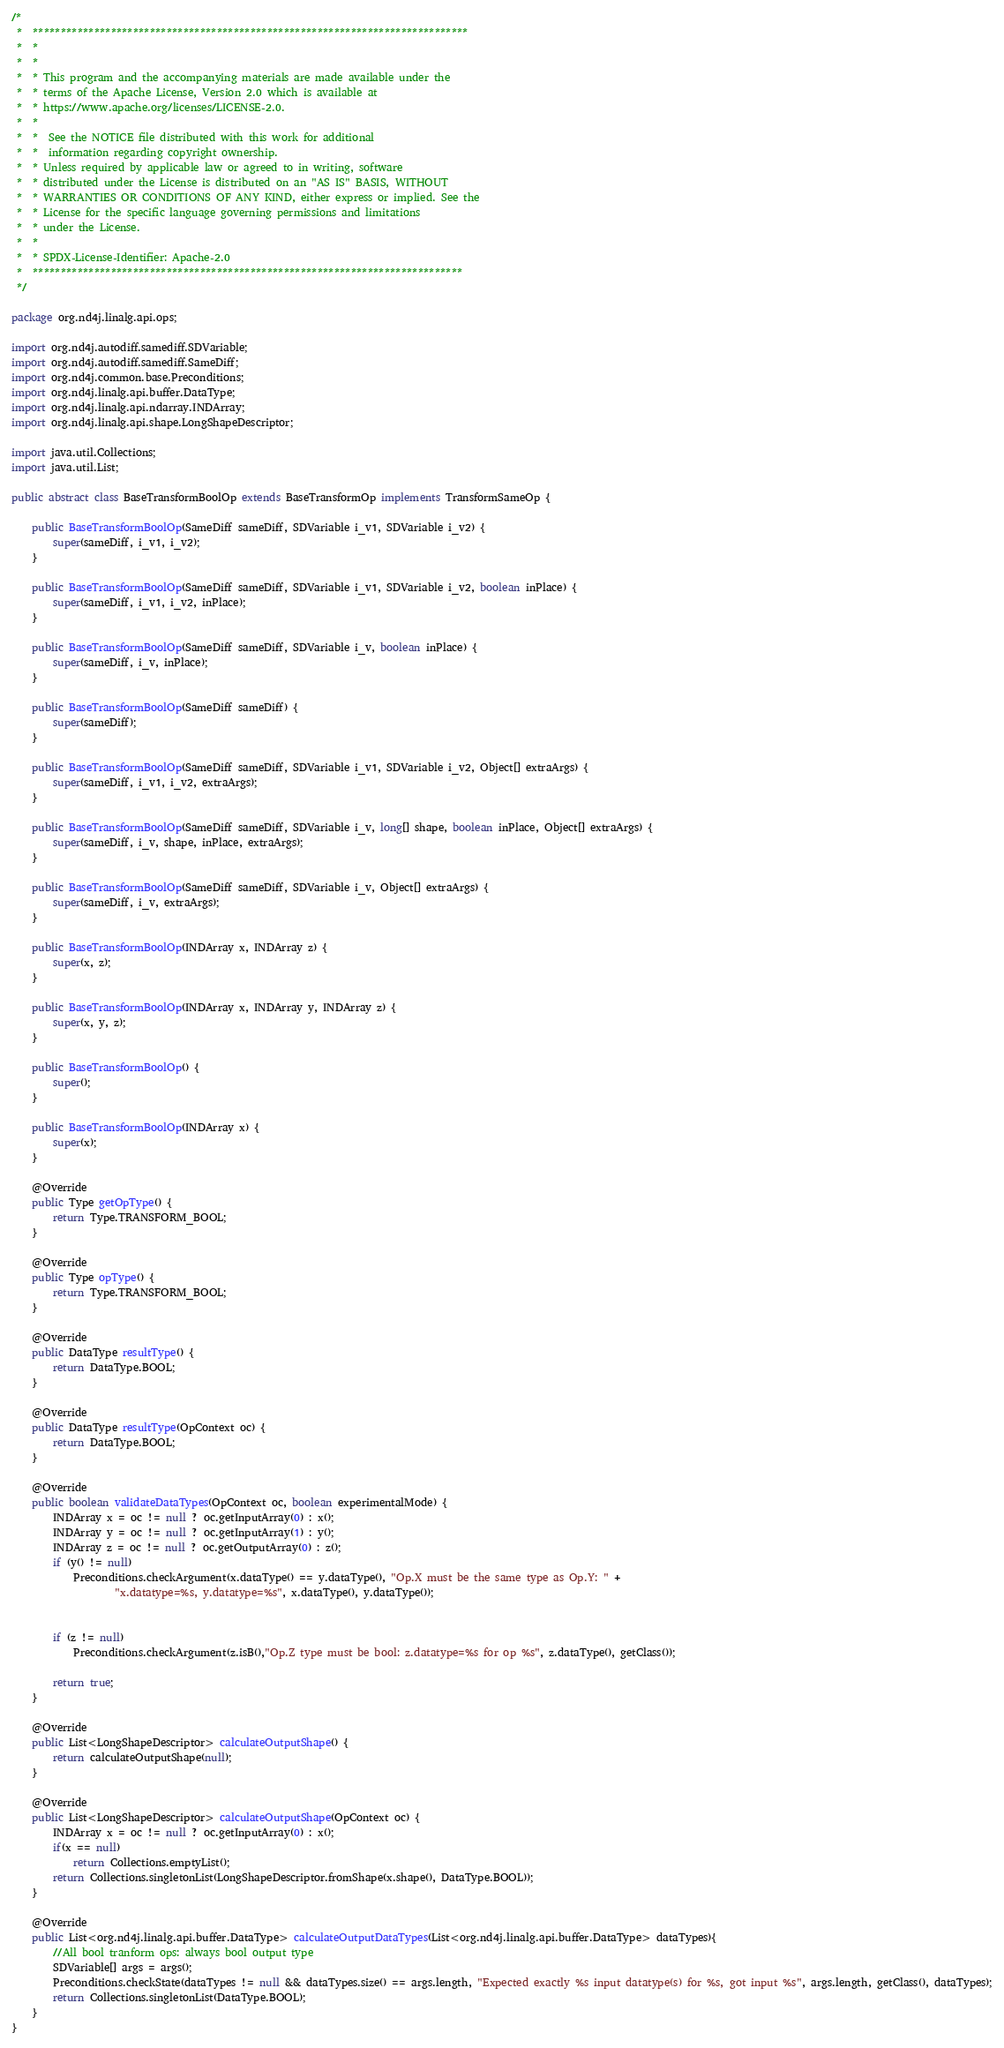<code> <loc_0><loc_0><loc_500><loc_500><_Java_>/*
 *  ******************************************************************************
 *  *
 *  *
 *  * This program and the accompanying materials are made available under the
 *  * terms of the Apache License, Version 2.0 which is available at
 *  * https://www.apache.org/licenses/LICENSE-2.0.
 *  *
 *  *  See the NOTICE file distributed with this work for additional
 *  *  information regarding copyright ownership.
 *  * Unless required by applicable law or agreed to in writing, software
 *  * distributed under the License is distributed on an "AS IS" BASIS, WITHOUT
 *  * WARRANTIES OR CONDITIONS OF ANY KIND, either express or implied. See the
 *  * License for the specific language governing permissions and limitations
 *  * under the License.
 *  *
 *  * SPDX-License-Identifier: Apache-2.0
 *  *****************************************************************************
 */

package org.nd4j.linalg.api.ops;

import org.nd4j.autodiff.samediff.SDVariable;
import org.nd4j.autodiff.samediff.SameDiff;
import org.nd4j.common.base.Preconditions;
import org.nd4j.linalg.api.buffer.DataType;
import org.nd4j.linalg.api.ndarray.INDArray;
import org.nd4j.linalg.api.shape.LongShapeDescriptor;

import java.util.Collections;
import java.util.List;

public abstract class BaseTransformBoolOp extends BaseTransformOp implements TransformSameOp {

    public BaseTransformBoolOp(SameDiff sameDiff, SDVariable i_v1, SDVariable i_v2) {
        super(sameDiff, i_v1, i_v2);
    }

    public BaseTransformBoolOp(SameDiff sameDiff, SDVariable i_v1, SDVariable i_v2, boolean inPlace) {
        super(sameDiff, i_v1, i_v2, inPlace);
    }

    public BaseTransformBoolOp(SameDiff sameDiff, SDVariable i_v, boolean inPlace) {
        super(sameDiff, i_v, inPlace);
    }

    public BaseTransformBoolOp(SameDiff sameDiff) {
        super(sameDiff);
    }

    public BaseTransformBoolOp(SameDiff sameDiff, SDVariable i_v1, SDVariable i_v2, Object[] extraArgs) {
        super(sameDiff, i_v1, i_v2, extraArgs);
    }

    public BaseTransformBoolOp(SameDiff sameDiff, SDVariable i_v, long[] shape, boolean inPlace, Object[] extraArgs) {
        super(sameDiff, i_v, shape, inPlace, extraArgs);
    }

    public BaseTransformBoolOp(SameDiff sameDiff, SDVariable i_v, Object[] extraArgs) {
        super(sameDiff, i_v, extraArgs);
    }

    public BaseTransformBoolOp(INDArray x, INDArray z) {
        super(x, z);
    }

    public BaseTransformBoolOp(INDArray x, INDArray y, INDArray z) {
        super(x, y, z);
    }

    public BaseTransformBoolOp() {
        super();
    }

    public BaseTransformBoolOp(INDArray x) {
        super(x);
    }

    @Override
    public Type getOpType() {
        return Type.TRANSFORM_BOOL;
    }

    @Override
    public Type opType() {
        return Type.TRANSFORM_BOOL;
    }

    @Override
    public DataType resultType() {
        return DataType.BOOL;
    }

    @Override
    public DataType resultType(OpContext oc) {
        return DataType.BOOL;
    }

    @Override
    public boolean validateDataTypes(OpContext oc, boolean experimentalMode) {
        INDArray x = oc != null ? oc.getInputArray(0) : x();
        INDArray y = oc != null ? oc.getInputArray(1) : y();
        INDArray z = oc != null ? oc.getOutputArray(0) : z();
        if (y() != null)
            Preconditions.checkArgument(x.dataType() == y.dataType(), "Op.X must be the same type as Op.Y: " +
                    "x.datatype=%s, y.datatype=%s", x.dataType(), y.dataType());


        if (z != null)
            Preconditions.checkArgument(z.isB(),"Op.Z type must be bool: z.datatype=%s for op %s", z.dataType(), getClass());

        return true;
    }

    @Override
    public List<LongShapeDescriptor> calculateOutputShape() {
        return calculateOutputShape(null);
    }

    @Override
    public List<LongShapeDescriptor> calculateOutputShape(OpContext oc) {
        INDArray x = oc != null ? oc.getInputArray(0) : x();
        if(x == null)
            return Collections.emptyList();
        return Collections.singletonList(LongShapeDescriptor.fromShape(x.shape(), DataType.BOOL));
    }

    @Override
    public List<org.nd4j.linalg.api.buffer.DataType> calculateOutputDataTypes(List<org.nd4j.linalg.api.buffer.DataType> dataTypes){
        //All bool tranform ops: always bool output type
        SDVariable[] args = args();
        Preconditions.checkState(dataTypes != null && dataTypes.size() == args.length, "Expected exactly %s input datatype(s) for %s, got input %s", args.length, getClass(), dataTypes);
        return Collections.singletonList(DataType.BOOL);
    }
}
</code> 